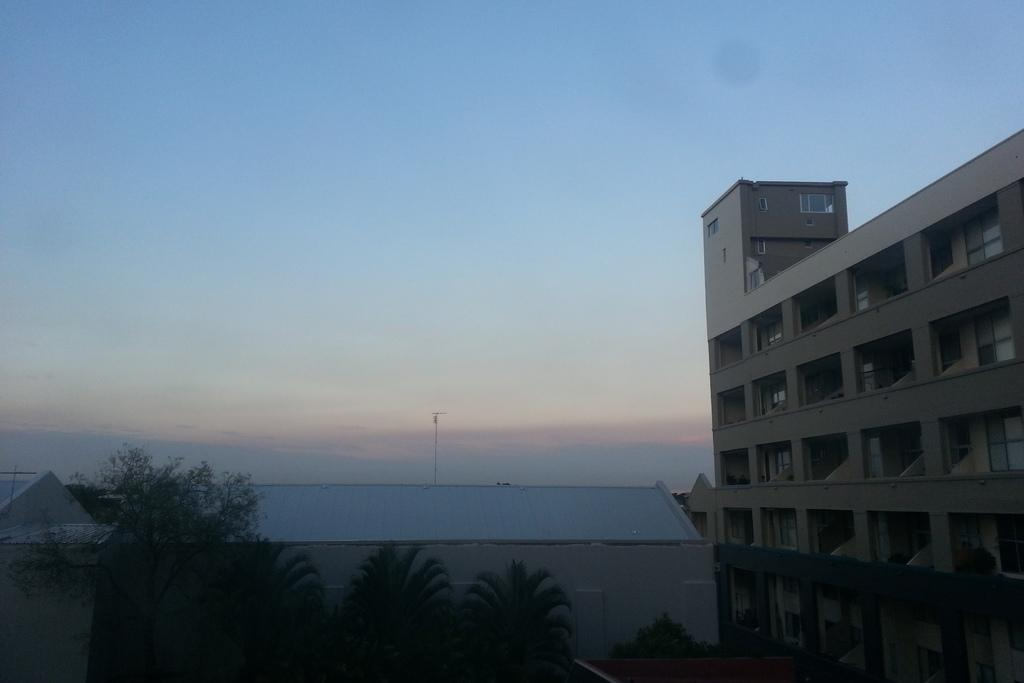What type of structures can be seen in the image? There are buildings in the image. What feature is visible on the buildings? There are windows visible in the image. What type of vegetation is present in the image? There are trees in the image. What object can be seen standing upright in the image? There is a pole in the image. What part of the natural environment is visible in the image? The sky is visible in the image. How many cows are grazing in the linen field in the image? There are no cows or linen fields present in the image. What type of fabric is being used to pull the pole in the image? There is no fabric or pulling action involving the pole in the image. 